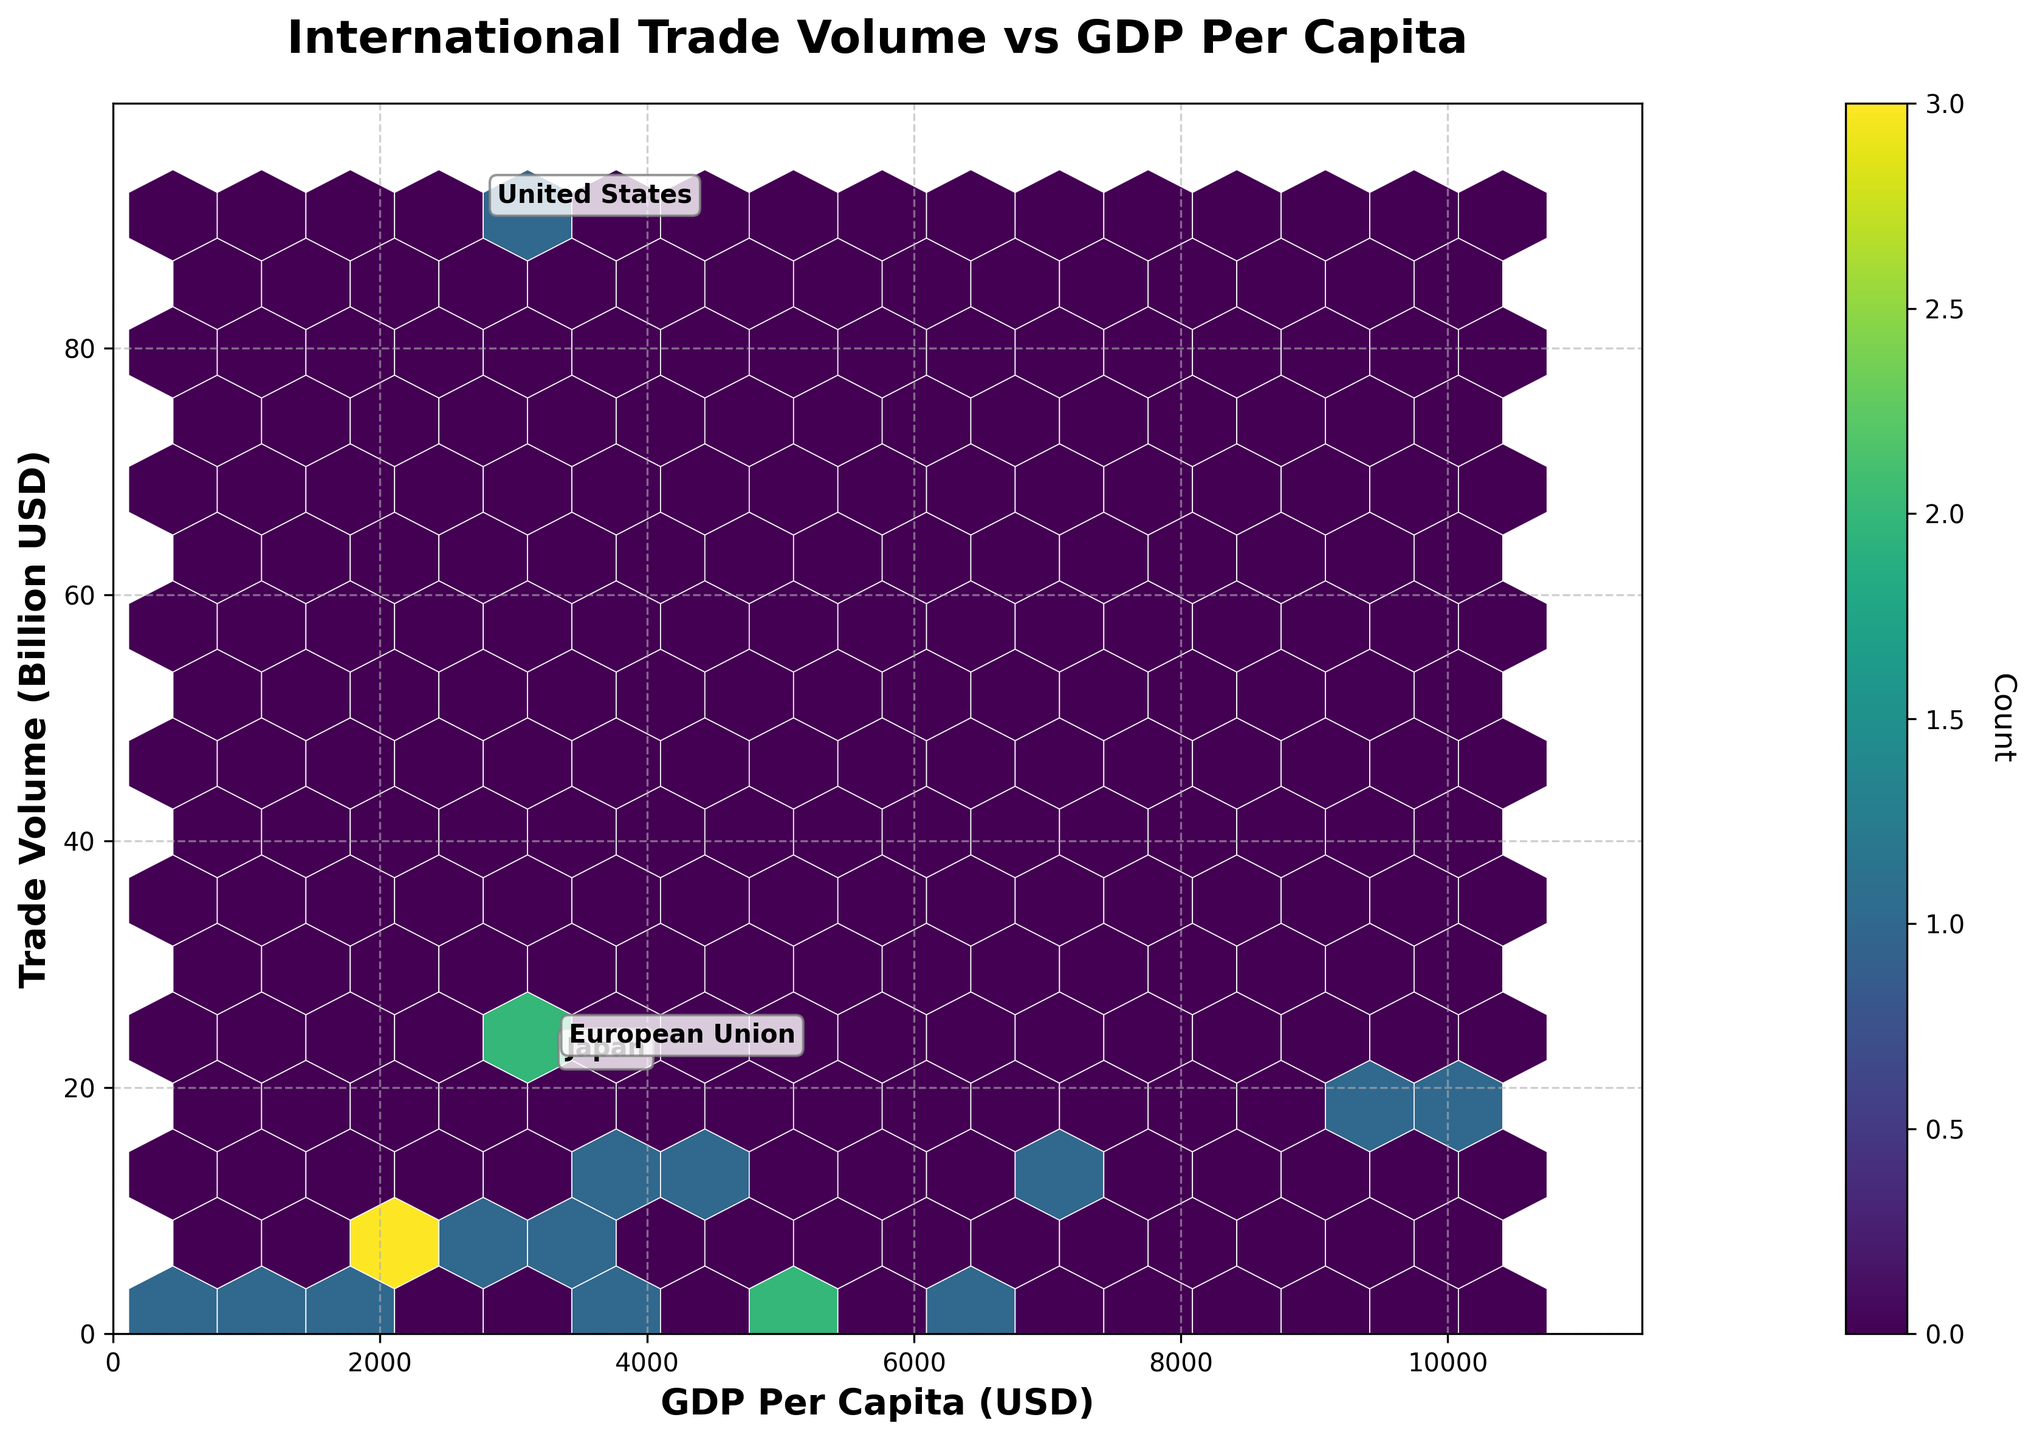What is the title of the Hexbin plot? The title is usually located at the top of the figure. In this plot, it is prominently displayed in bold and larger font size. The title mentions both "International Trade Volume" and "GDP Per Capita".
Answer: International Trade Volume vs GDP Per Capita What do the x and y axes represent in this plot? The labels of the axes provide this information clearly. The x-axis label reads "GDP Per Capita (USD)" and the y-axis label reads "Trade Volume (Billion USD)".
Answer: The x-axis represents GDP Per Capita (USD) and the y-axis represents Trade Volume (Billion USD) What color scheme is used in the hexbin plot, and what does it indicate? The plot uses a "viridis" colormap, which ranges from dark purple to yellow-green, and the color intensity indicates the count of data points in each hexagon.
Answer: The viridis colormap indicates the count of data points Which countries have been specifically annotated in the plot, and why? The annotations are based on the trade volume exceeding 20 billion USD. By looking at the annotated points, we can see the countries listed next to them. These points are United States, Japan, and European Union.
Answer: United States, Japan, and European Union Is there a noticeable correlation between GDP Per Capita and Trade Volume based on the hexbin plot? A hexbin plot reveals correlations through the density and spread of hexagons. The plot shows a scattered trend, suggesting that while there might be clusters, there is no strong linear correlation visible.
Answer: No strong correlation is noticeable Which country has a high trade volume with a relatively low GDP Per Capita from the hexbin plot? By examining the annotations and the position of points with high trade volumes, one can see that the European Union-Tunisia trade partner pairing stands out with substantial trade volume and a lower GDP per capita than others with high trade volumes.
Answer: European Union (with Tunisia) How many total data points or country pairs are visualized in the Hexbin plot? By counting the number of hexagons displayed, especially where the color intensity is lower, as well as the annotations, the total number of data points is around 19, matching the provided data.
Answer: 19 Which range of GDP Per Capita seems to have the highest trade activity based on the color intensity? Observing the color gradients, the most intense hexagons (darkest) reflect the highest activity and are located approximately between 2,000 and 4,000 USD GDP Per Capita.
Answer: 2,000 to 4,000 USD Is there any visible outlier in terms of trade volume, when compared to GDP Per Capita? The plot shows certain points significantly higher in trade volume than others, specifically annotated countries like the European Union with Tunisia, United States with Vietnam, and Japan with Philippines suggest outliers.
Answer: European Union (with Tunisia), United States (with Vietnam), Japan (with Philippines) What can you infer about the trade relationship between South Korea and Thailand compared to Germany and Indonesia based on their positions on the plot? South Korea-Thailand and Germany-Indonesia data points are positioned close to one another on the hexbin, but Korea-Thailand has a slightly higher trade volume and lower GDP per capita compared to Germany-Indonesia. So, South Korea and Thailand engage in more trade volume relative to their GDP.
Answer: South Korea trades more with Thailand than Germany does with Indonesia 